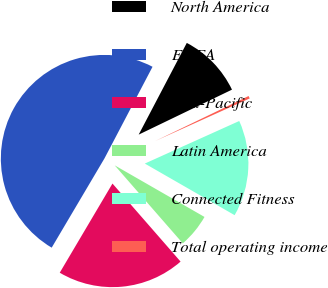Convert chart. <chart><loc_0><loc_0><loc_500><loc_500><pie_chart><fcel>North America<fcel>EMEA<fcel>Asia-Pacific<fcel>Latin America<fcel>Connected Fitness<fcel>Total operating income<nl><fcel>10.16%<fcel>49.19%<fcel>19.92%<fcel>5.28%<fcel>15.04%<fcel>0.41%<nl></chart> 